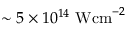<formula> <loc_0><loc_0><loc_500><loc_500>\sim 5 \times 1 0 ^ { 1 4 } W c m ^ { - 2 }</formula> 